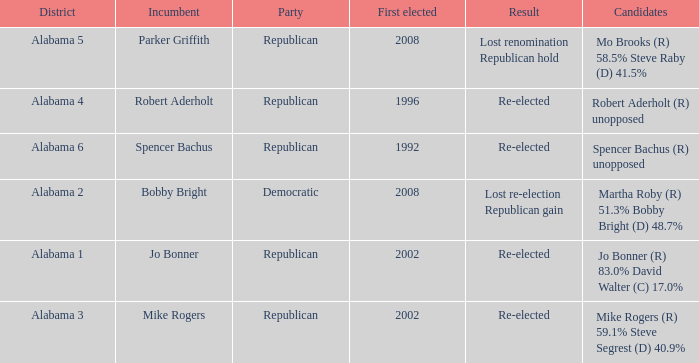Could you parse the entire table? {'header': ['District', 'Incumbent', 'Party', 'First elected', 'Result', 'Candidates'], 'rows': [['Alabama 5', 'Parker Griffith', 'Republican', '2008', 'Lost renomination Republican hold', 'Mo Brooks (R) 58.5% Steve Raby (D) 41.5%'], ['Alabama 4', 'Robert Aderholt', 'Republican', '1996', 'Re-elected', 'Robert Aderholt (R) unopposed'], ['Alabama 6', 'Spencer Bachus', 'Republican', '1992', 'Re-elected', 'Spencer Bachus (R) unopposed'], ['Alabama 2', 'Bobby Bright', 'Democratic', '2008', 'Lost re-election Republican gain', 'Martha Roby (R) 51.3% Bobby Bright (D) 48.7%'], ['Alabama 1', 'Jo Bonner', 'Republican', '2002', 'Re-elected', 'Jo Bonner (R) 83.0% David Walter (C) 17.0%'], ['Alabama 3', 'Mike Rogers', 'Republican', '2002', 'Re-elected', 'Mike Rogers (R) 59.1% Steve Segrest (D) 40.9%']]} Name the result for first elected being 1992 Re-elected. 